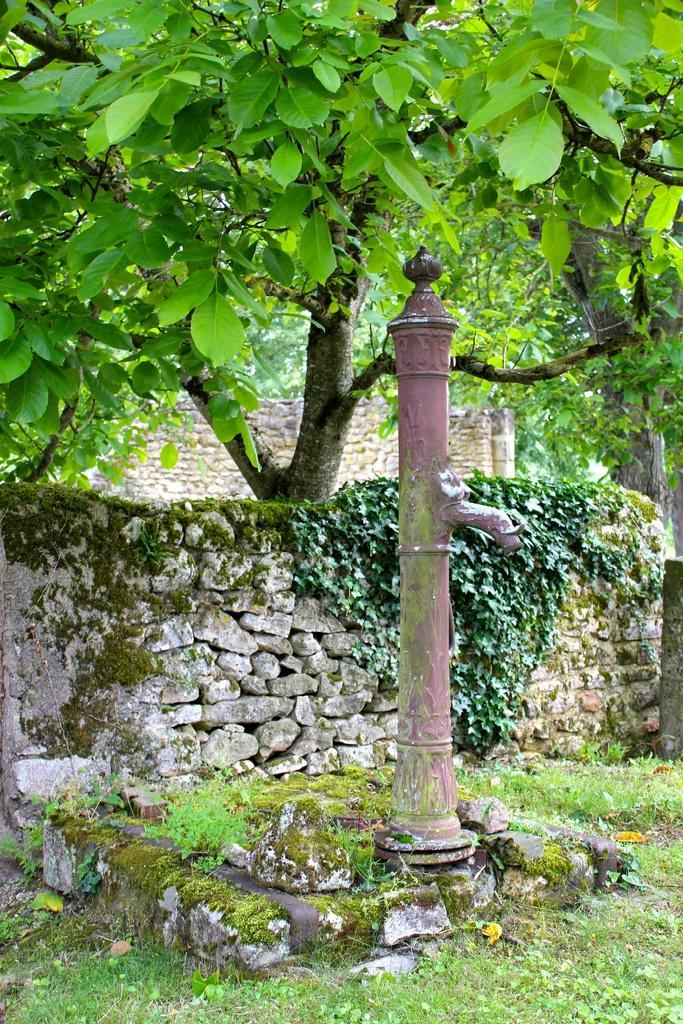How would you summarize this image in a sentence or two? In this picture we can observe a water pump. There are some stones on the ground. We can observe some grass and plants here. There is a stone wall behind this pump. In the background there are trees. 